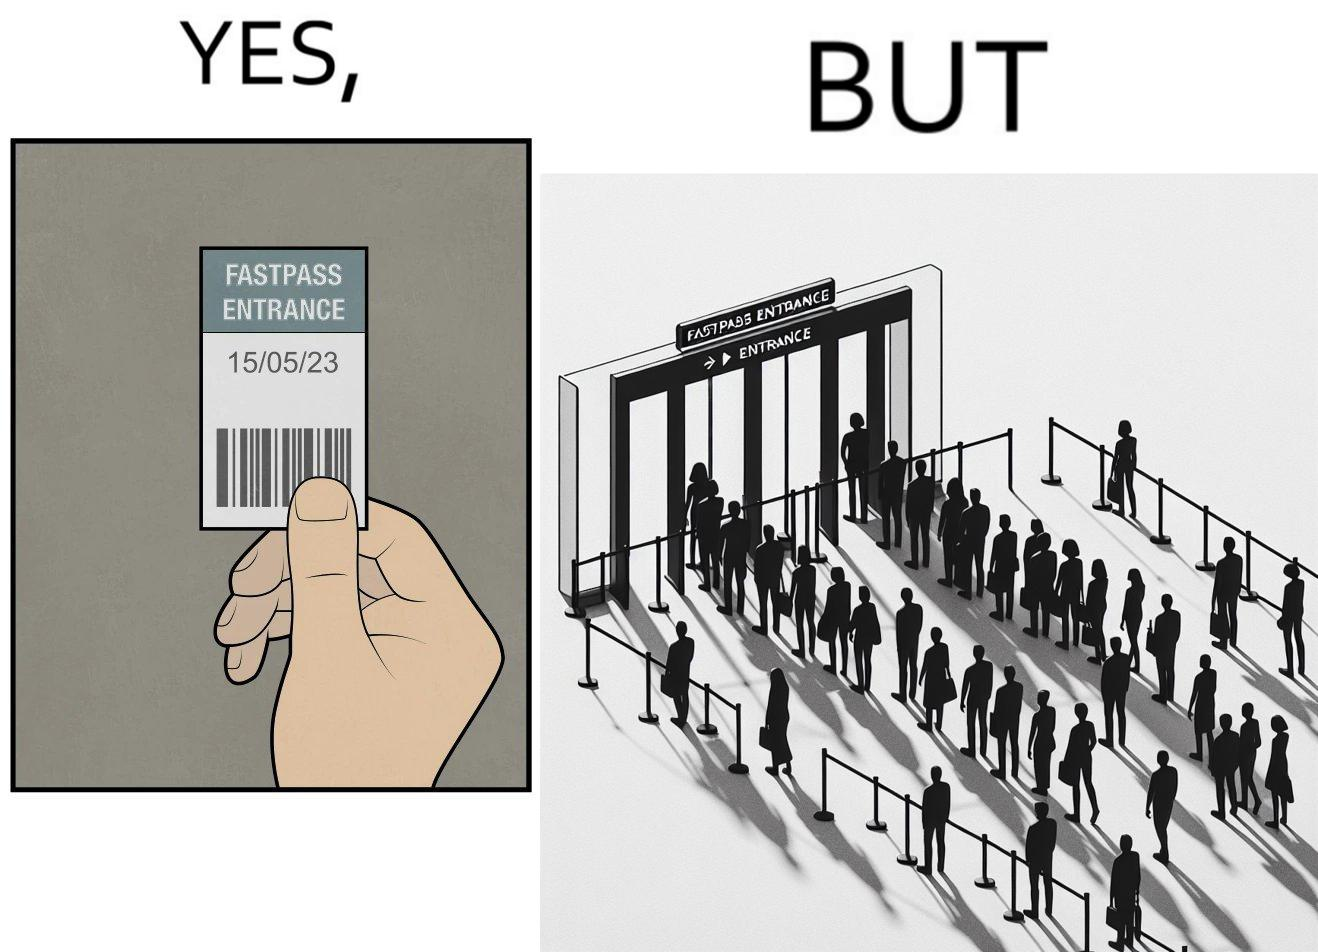Describe the satirical element in this image. The image is ironic, because fast pass entrance was meant for people to pass the gate fast but as more no. of people bought the pass due to which the queue has become longer and it becomes slow and time consuming 